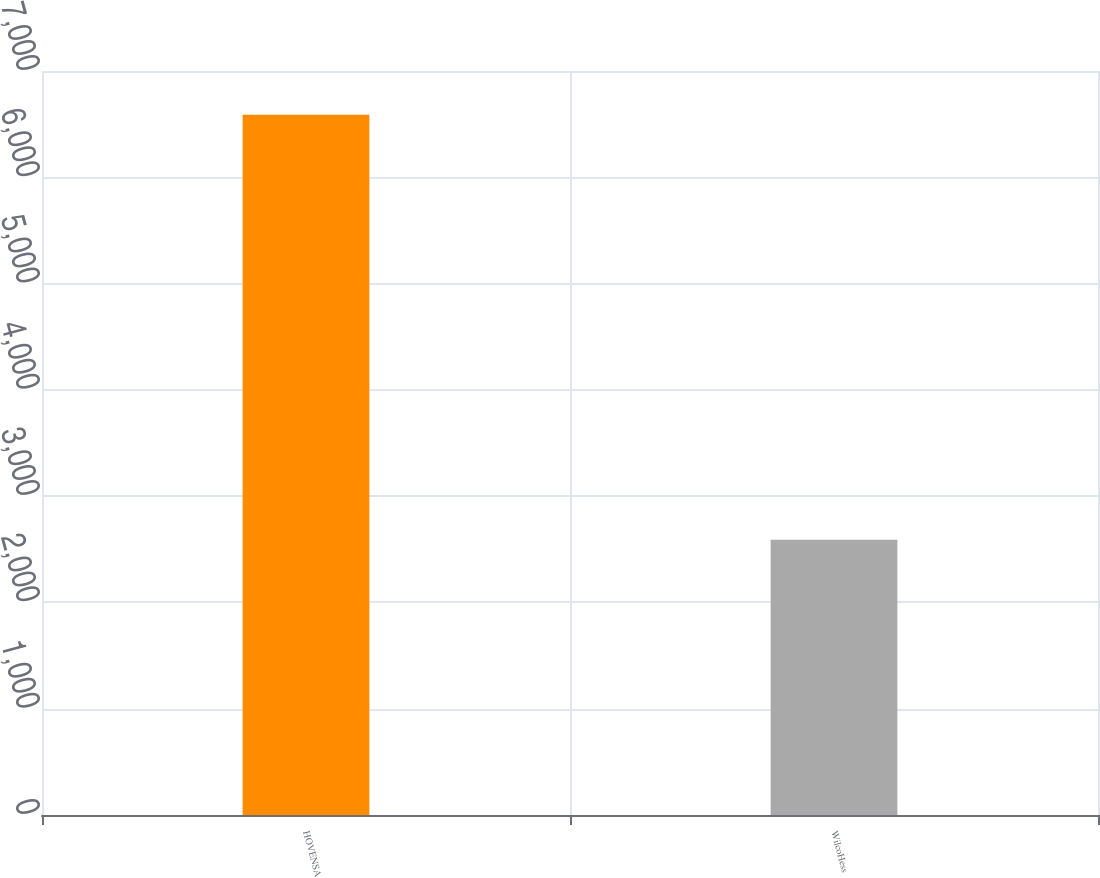<chart> <loc_0><loc_0><loc_500><loc_500><bar_chart><fcel>HOVENSA<fcel>WilcoHess<nl><fcel>6589<fcel>2590<nl></chart> 